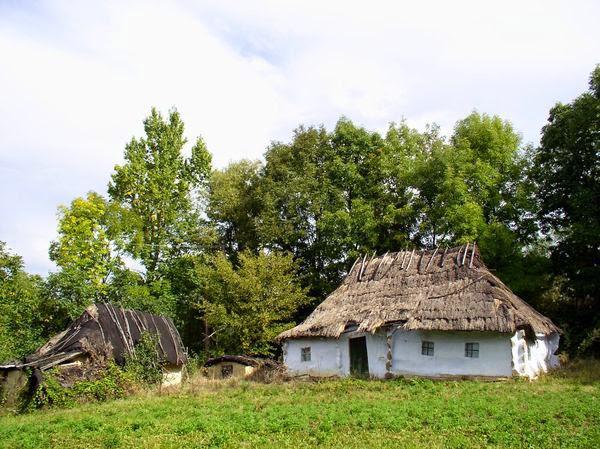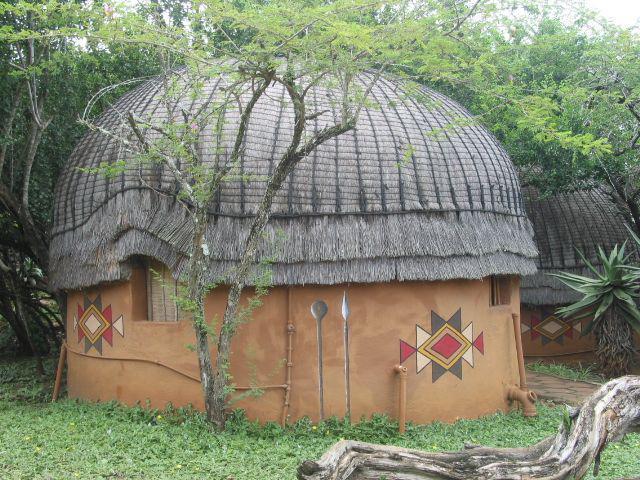The first image is the image on the left, the second image is the image on the right. Assess this claim about the two images: "There are two chimneys.". Correct or not? Answer yes or no. No. The first image is the image on the left, the second image is the image on the right. Assess this claim about the two images: "The walls of one of the thatched houses is covered with a climbing vine, maybe ivy.". Correct or not? Answer yes or no. No. 